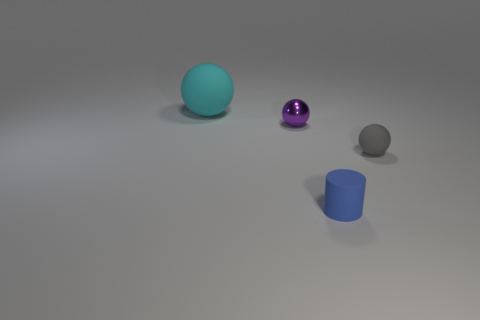What can you infer about the lighting and shadows in the scene? The lighting in the scene suggests a single diffuse light source coming from the upper left, as indicated by the soft shadows cast to the lower right of the objects. The absence of harsh shadows implies that the light source is not extremely bright or close to the objects. 